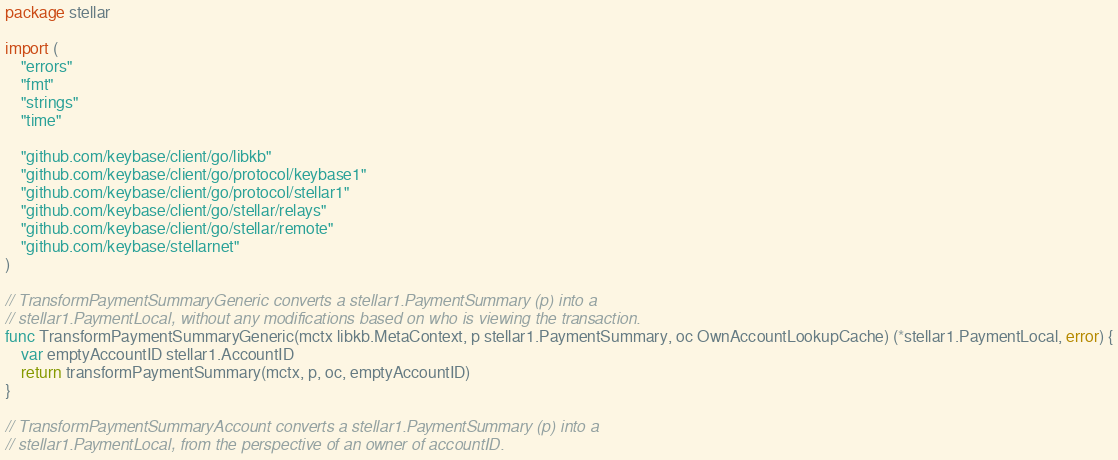<code> <loc_0><loc_0><loc_500><loc_500><_Go_>package stellar

import (
	"errors"
	"fmt"
	"strings"
	"time"

	"github.com/keybase/client/go/libkb"
	"github.com/keybase/client/go/protocol/keybase1"
	"github.com/keybase/client/go/protocol/stellar1"
	"github.com/keybase/client/go/stellar/relays"
	"github.com/keybase/client/go/stellar/remote"
	"github.com/keybase/stellarnet"
)

// TransformPaymentSummaryGeneric converts a stellar1.PaymentSummary (p) into a
// stellar1.PaymentLocal, without any modifications based on who is viewing the transaction.
func TransformPaymentSummaryGeneric(mctx libkb.MetaContext, p stellar1.PaymentSummary, oc OwnAccountLookupCache) (*stellar1.PaymentLocal, error) {
	var emptyAccountID stellar1.AccountID
	return transformPaymentSummary(mctx, p, oc, emptyAccountID)
}

// TransformPaymentSummaryAccount converts a stellar1.PaymentSummary (p) into a
// stellar1.PaymentLocal, from the perspective of an owner of accountID.</code> 